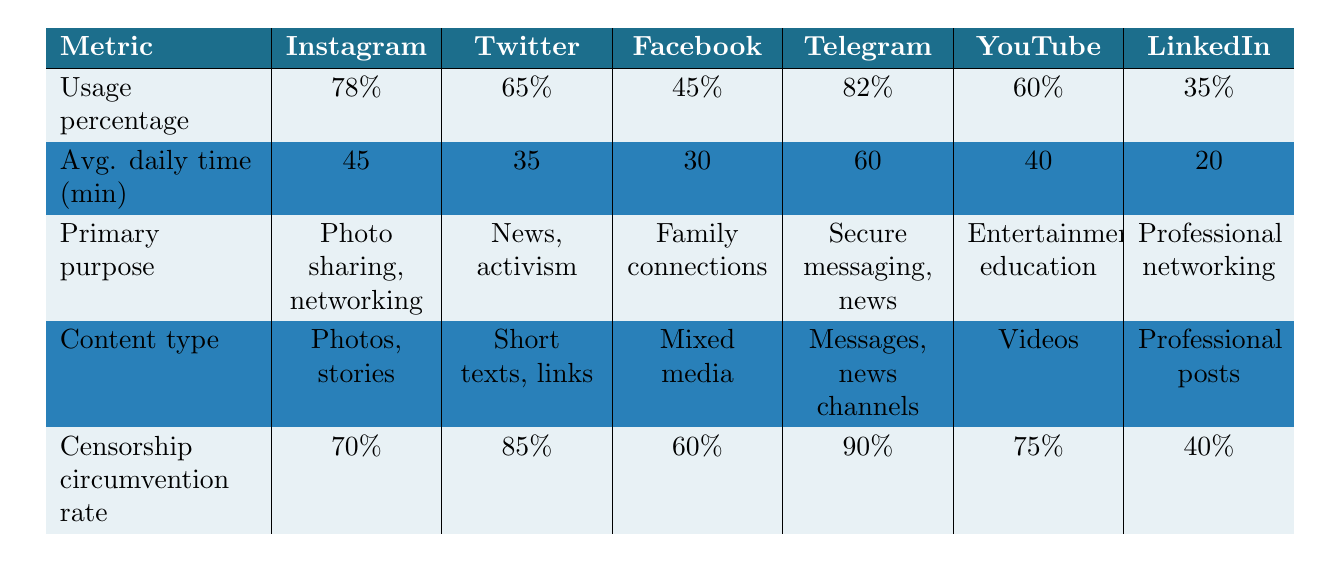What is the usage percentage of Telegram among the Iranian diaspora? The table lists the usage percentages of various platforms. Telegram has a usage percentage of 82%.
Answer: 82% Which platform has the highest average daily time spent? The average daily time spent on each platform is provided in the table. Comparing the values, Telegram has the highest average daily time spent at 60 minutes.
Answer: Telegram Is the primary purpose of LinkedIn professional networking? According to the table, the primary purpose of LinkedIn is "Professional networking," which confirms the statement as true.
Answer: Yes What is the difference in censorship circumvention rates between Twitter and Facebook? The censorship circumvention rate for Twitter is 85% and for Facebook is 60%. Thus, the difference is 85% - 60% = 25%.
Answer: 25% Which platform has the lowest usage percentage and what is it? By reviewing the usage percentages listed, Facebook has the lowest usage percentage at 45%.
Answer: Facebook, 45% What is the average daily time spent across Instagram and YouTube? The average daily time for Instagram is 45 minutes and for YouTube is 40 minutes. The total time spent is 45 + 40 = 85 minutes. To find the average, we divide by 2: 85/2 = 42.5 minutes.
Answer: 42.5 minutes True or False: YouTube's primary purpose is for secure messaging and news. The table specifies that the primary purpose of YouTube is "Entertainment, education," not secure messaging and news, making the statement false.
Answer: False Which platform has the highest censorship circumvention rate, and what is that rate? The table indicates the censorship circumvention rates for each platform. Telegram has the highest rate at 90%.
Answer: Telegram, 90% Calculate the total average daily time spent for all platforms combined. The average daily times spent are as follows: Instagram (45), Twitter (35), Facebook (30), Telegram (60), YouTube (40), LinkedIn (20). We sum these values: 45 + 35 + 30 + 60 + 40 + 20 = 230 minutes. To find the average for the 6 platforms, we divide by 6: 230/6 = 38.33 minutes.
Answer: 38.33 minutes 